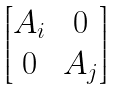<formula> <loc_0><loc_0><loc_500><loc_500>\begin{bmatrix} A _ { i } & 0 \\ 0 & A _ { j } \end{bmatrix}</formula> 